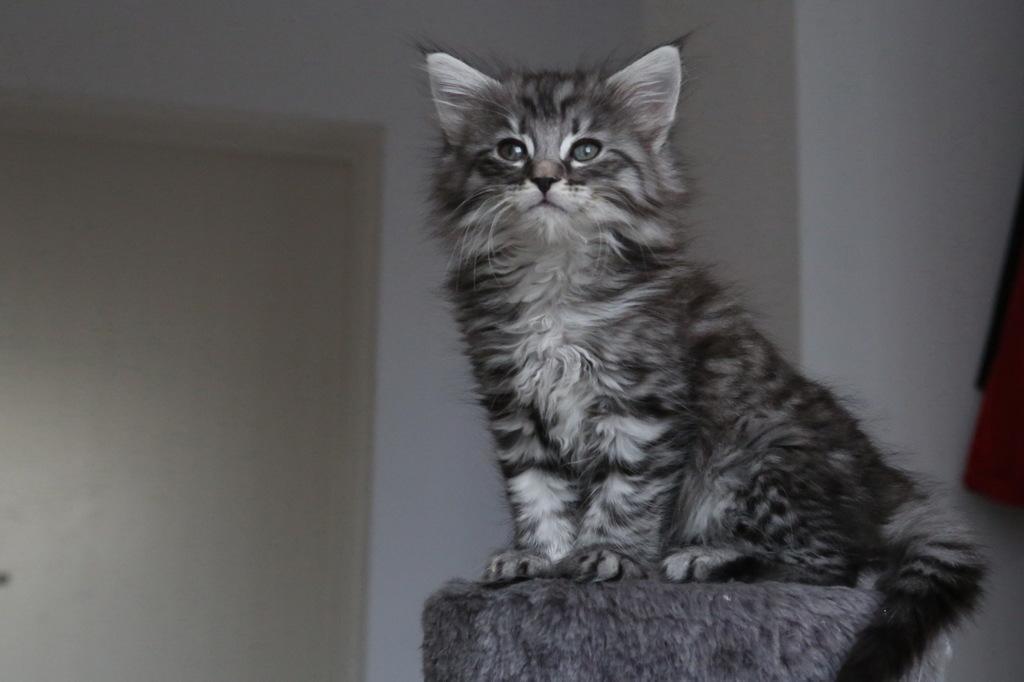In one or two sentences, can you explain what this image depicts? In this picture we can see a cat sitting on an object. Behind the cat there is a door and the wall. On the right side of the image, there are some objects. 